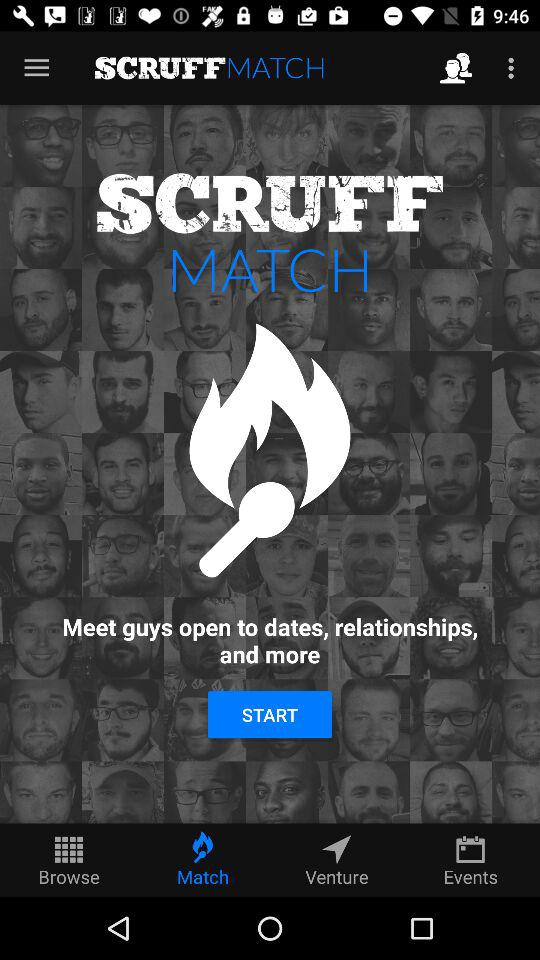What is the name of the application? The name of the application is "SCRUFFMATCH". 